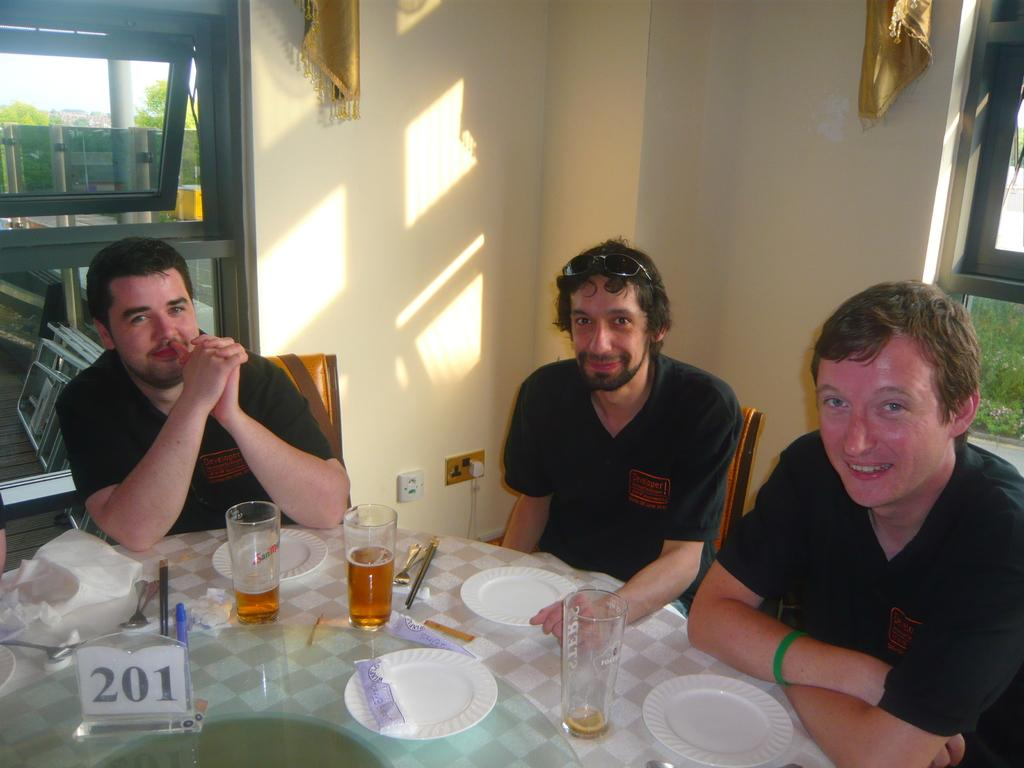How many men are sitting in the image? There are three men sitting on chairs in the image. What objects can be seen on the table? There is a glass, a plate, and a tissue on the table. What is the material of the cloth mentioned in the facts? The facts do not specify the material of the cloth. What can be seen in the background of the image? There are trees in the background of the image. What direction are the men facing in the image? The facts do not specify the direction the men are facing in the image. How many thumbs can be seen in the image? The facts do not mention any thumbs in the image. What route are the men taking in the image? The facts do not mention any route or movement in the image. 